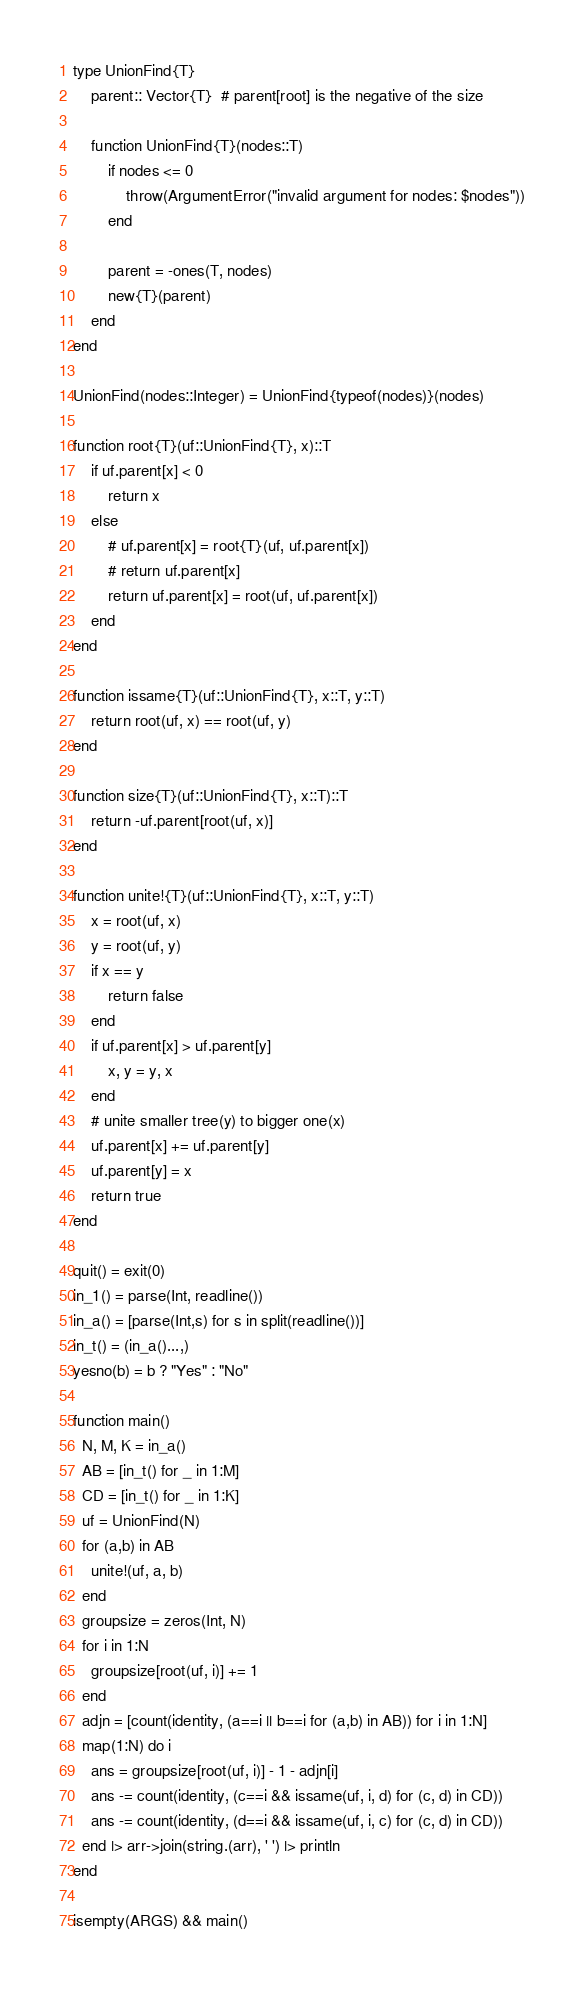Convert code to text. <code><loc_0><loc_0><loc_500><loc_500><_Julia_>type UnionFind{T}
    parent:: Vector{T}  # parent[root] is the negative of the size

    function UnionFind{T}(nodes::T)
        if nodes <= 0
            throw(ArgumentError("invalid argument for nodes: $nodes"))
        end

        parent = -ones(T, nodes)
        new{T}(parent)
    end
end

UnionFind(nodes::Integer) = UnionFind{typeof(nodes)}(nodes)

function root{T}(uf::UnionFind{T}, x)::T
    if uf.parent[x] < 0
        return x
    else
        # uf.parent[x] = root{T}(uf, uf.parent[x])
        # return uf.parent[x]
        return uf.parent[x] = root(uf, uf.parent[x])
    end
end

function issame{T}(uf::UnionFind{T}, x::T, y::T)
    return root(uf, x) == root(uf, y)
end

function size{T}(uf::UnionFind{T}, x::T)::T
    return -uf.parent[root(uf, x)]
end

function unite!{T}(uf::UnionFind{T}, x::T, y::T)
    x = root(uf, x)
    y = root(uf, y)
    if x == y
        return false
    end
    if uf.parent[x] > uf.parent[y]
        x, y = y, x
    end
    # unite smaller tree(y) to bigger one(x)
    uf.parent[x] += uf.parent[y]
    uf.parent[y] = x
    return true
end

quit() = exit(0)
in_1() = parse(Int, readline())
in_a() = [parse(Int,s) for s in split(readline())]
in_t() = (in_a()...,)
yesno(b) = b ? "Yes" : "No"

function main()
  N, M, K = in_a()
  AB = [in_t() for _ in 1:M]
  CD = [in_t() for _ in 1:K]
  uf = UnionFind(N)
  for (a,b) in AB
    unite!(uf, a, b)
  end
  groupsize = zeros(Int, N)
  for i in 1:N
    groupsize[root(uf, i)] += 1
  end
  adjn = [count(identity, (a==i || b==i for (a,b) in AB)) for i in 1:N]
  map(1:N) do i
    ans = groupsize[root(uf, i)] - 1 - adjn[i]
    ans -= count(identity, (c==i && issame(uf, i, d) for (c, d) in CD))
    ans -= count(identity, (d==i && issame(uf, i, c) for (c, d) in CD))
  end |> arr->join(string.(arr), ' ') |> println
end

isempty(ARGS) && main()
</code> 